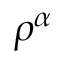<formula> <loc_0><loc_0><loc_500><loc_500>\rho ^ { \alpha }</formula> 